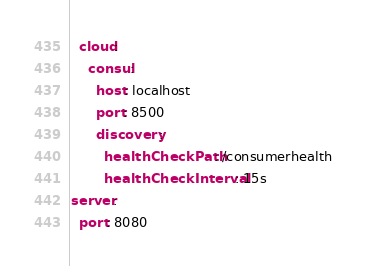<code> <loc_0><loc_0><loc_500><loc_500><_YAML_>  cloud:
    consul:
      host: localhost
      port: 8500
      discovery:
        healthCheckPath: /consumerhealth
        healthCheckInterval: 15s
server:
  port: 8080</code> 